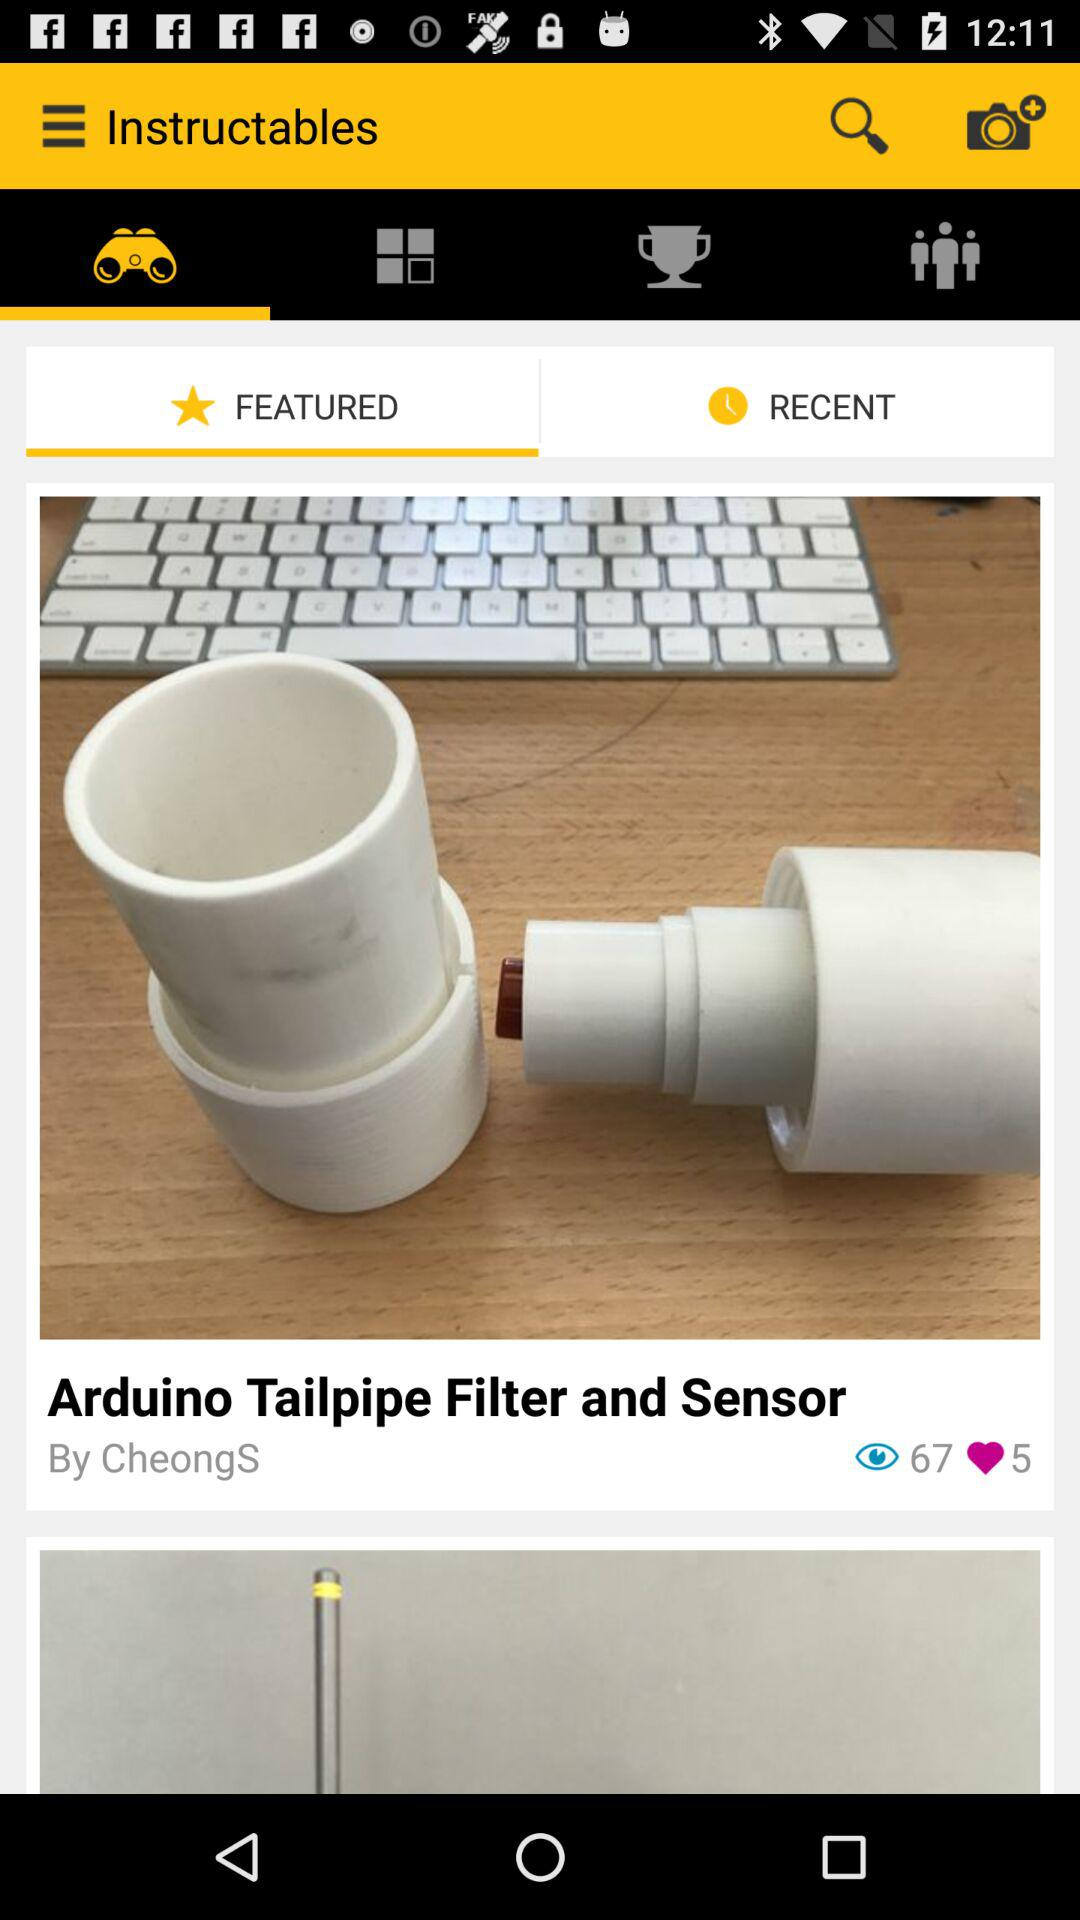How many views are there of "Arduino Tailpipe Filter and Sensor"? There are 67 views of "Arduino Tailpipe Filter and Sensor". 